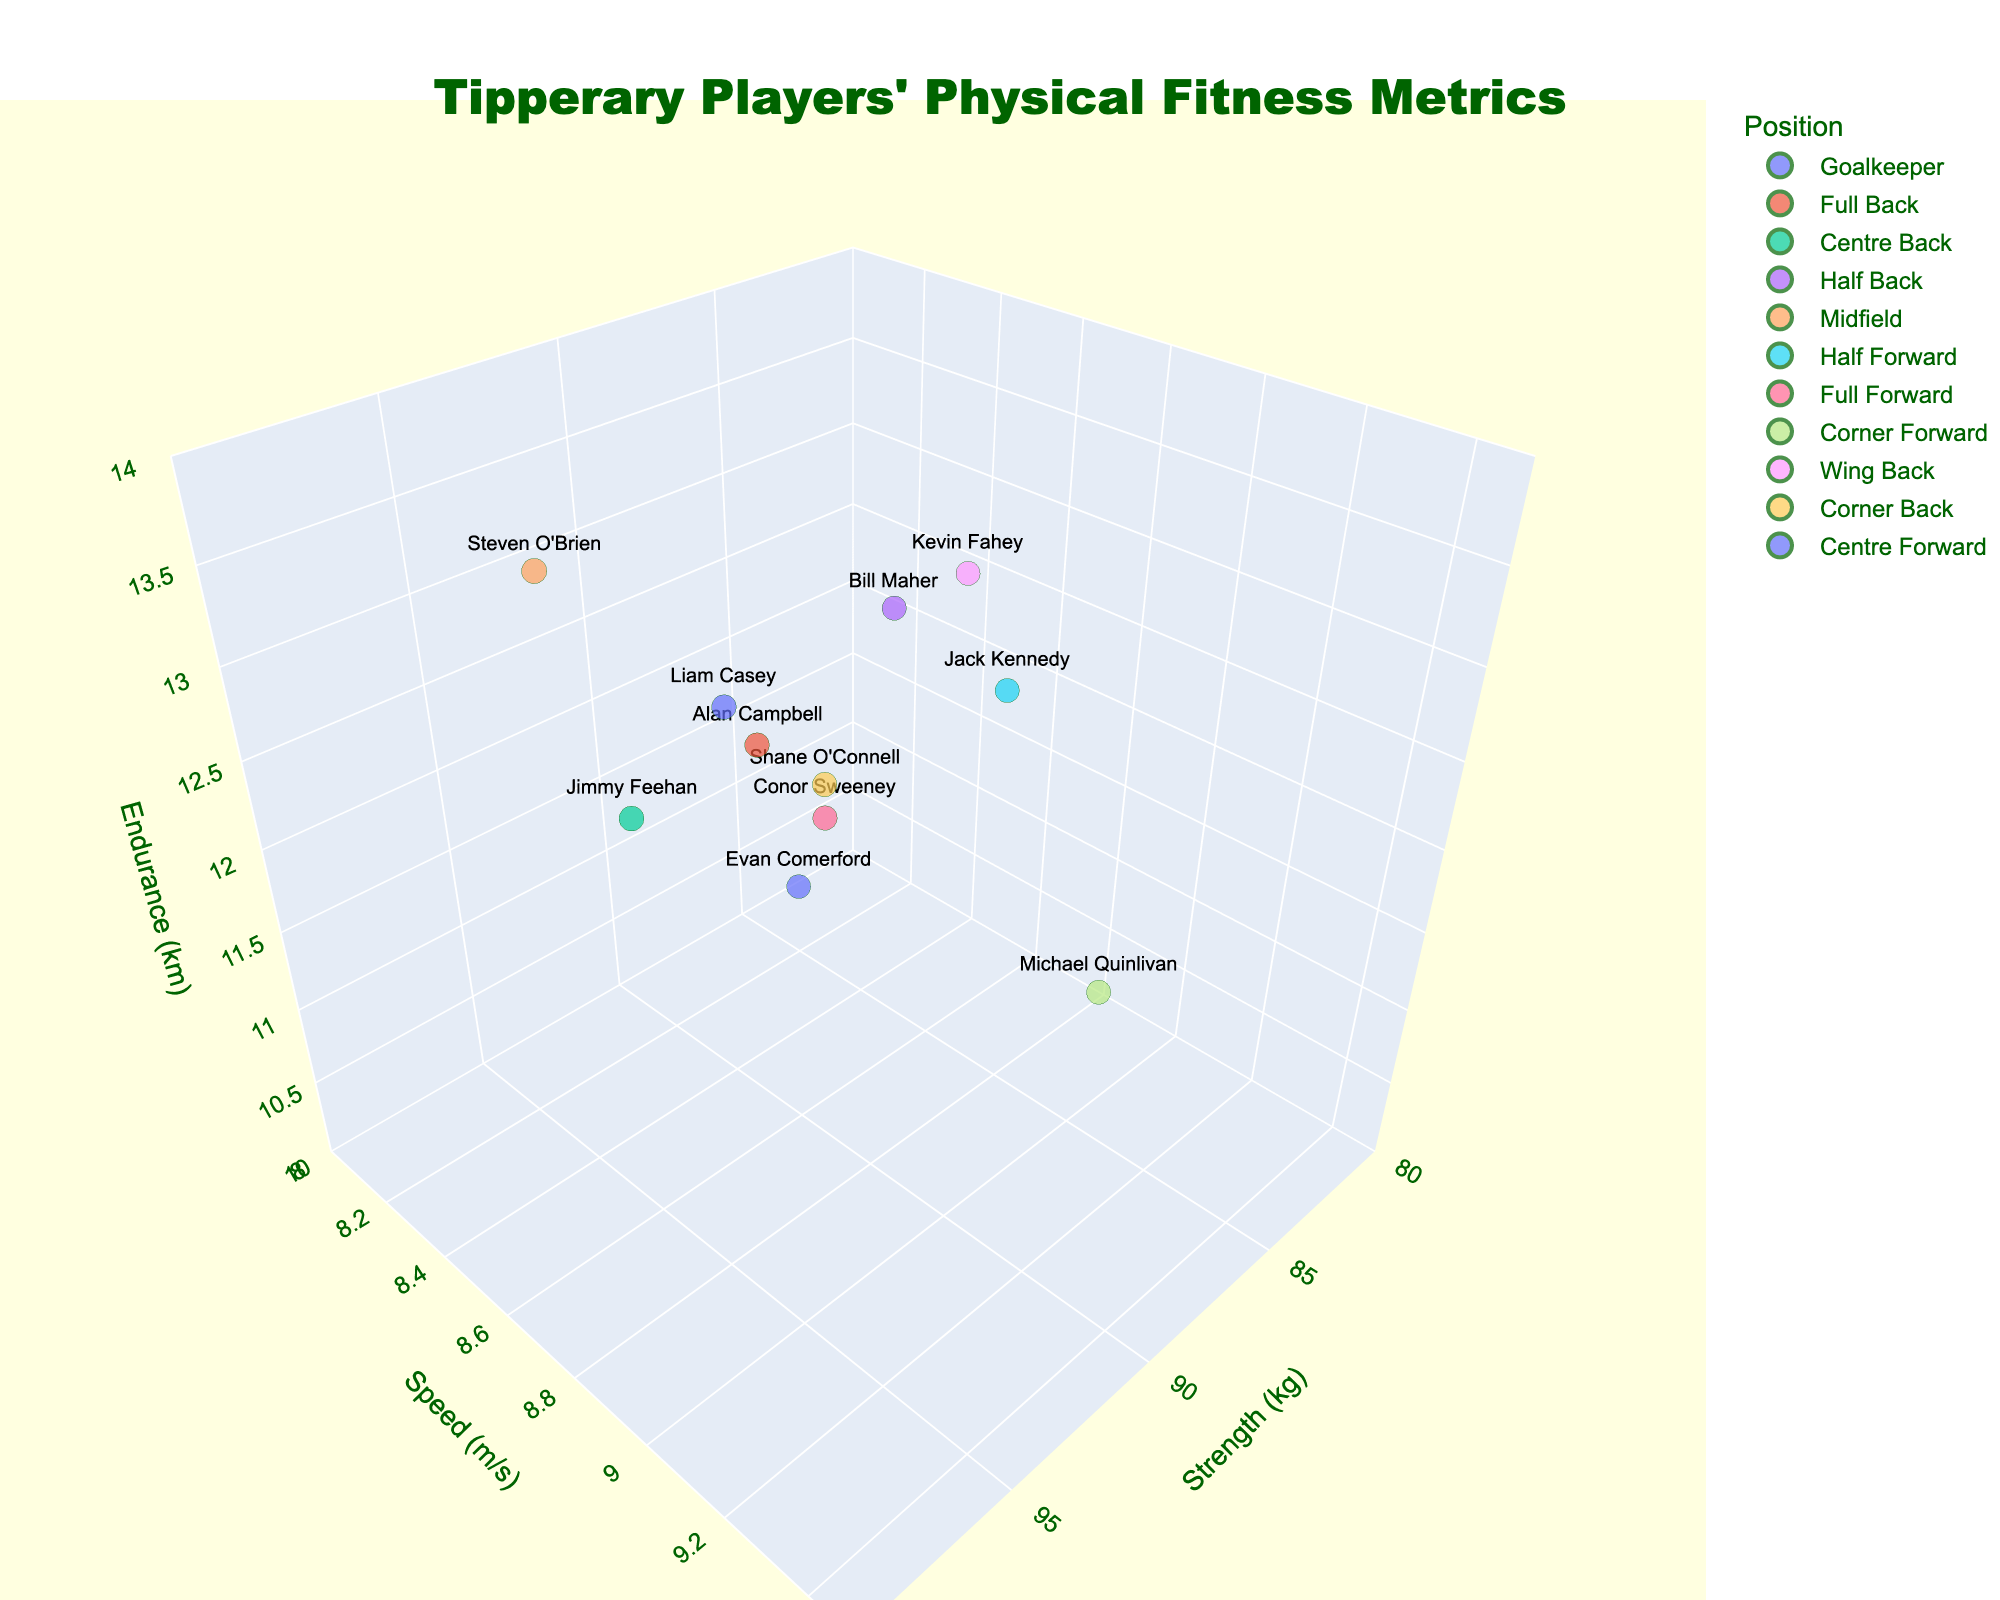What's the title of the 3D plot? The title of the 3D plot is located at the top center of the figure. It is "Tipperary Players' Physical Fitness Metrics".
Answer: Tipperary Players' Physical Fitness Metrics How many players are represented in the plot? Each data point represents a player, so we count the number of data points. There are 11 data points in the plot
Answer: 11 Which player has the highest speed? By looking at the y-axis labelled "Speed (m/s)", and identifying the highest data point along that axis, we find that Michael Quinlivan in the Corner Forward position has the highest speed of 9.1 m/s.
Answer: Michael Quinlivan What is the average endurance of the players in the plot? To calculate the average endurance, sum up all the endurance values: 10.5 + 12.3 + 11.8 + 13.1 + 13.5 + 12.8 + 11.9 + 11.2 + 13.3 + 12.1 + 12.6 which equals 134.1. Then divide by the number of players, which is 11. So, the average endurance is 134.1/11.
Answer: 12.19 Which position has the player with the highest strength? Observing the x-axis labelled "Strength (kg)", we find that the highest value of 95 kg is for Steven O'Brien in the Midfield position.
Answer: Midfield Compare the speed and strength of Conor Sweeney and Alan Campbell. Who has higher values in both metrics? Conor Sweeney has a speed of 8.6 m/s and strength of 89 kg. Alan Campbell has a speed of 8.5 m/s and strength of 90 kg. By comparing both metrics, Conor Sweeney has a higher speed, but Alan Campbell has higher strength.
Answer: Neither (one has higher speed, the other strength) Which player has the greatest endurance and what is their strength? The player with the highest z-coordinate on the z-axis (endurance) is Steven O'Brien with an endurance of 13.5 km. His strength (x-coordinate) is 95 kg.
Answer: Steven O'Brien, 95 kg Compare the speed of the Full Forward and Centre Forward positions. Which is higher? Conor Sweeney (Full Forward) has a speed of 8.6 m/s. Liam Casey (Centre Forward) has a speed of 8.5 m/s. Therefore, the Full Forward position has a higher speed.
Answer: Full Forward What is the difference in endurance between the Wing Back and Corner Forward positions? Kevin Fahey (Wing Back) has an endurance of 13.3 km, and Michael Quinlivan (Corner Forward) has an endurance of 11.2 km. The difference is 13.3 - 11.2 = 2.1 km.
Answer: 2.1 km Which player in the Half Back position has the highest endurance and what is the value? There is only one player listed in the Half Back position: Bill Maher with an endurance of 13.1 km.
Answer: Bill Maher, 13.1 km 